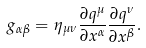<formula> <loc_0><loc_0><loc_500><loc_500>g _ { \alpha \beta } = \eta _ { \mu \nu } { \frac { \partial q ^ { \mu } } { \partial x ^ { \alpha } } } { \frac { \partial q ^ { \nu } } { \partial x ^ { \beta } } } .</formula> 